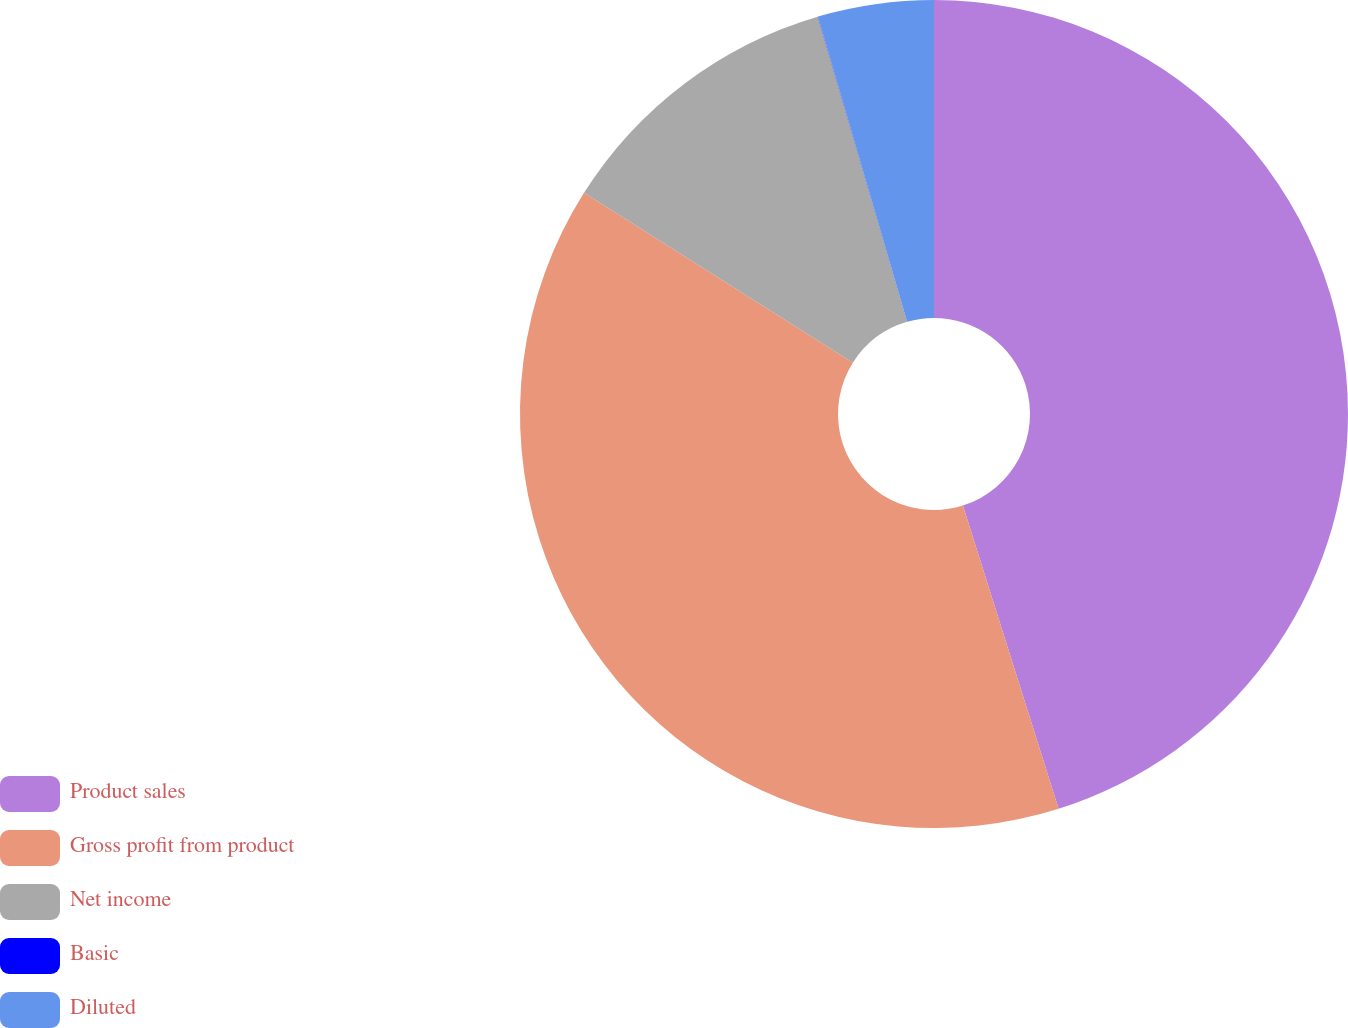Convert chart. <chart><loc_0><loc_0><loc_500><loc_500><pie_chart><fcel>Product sales<fcel>Gross profit from product<fcel>Net income<fcel>Basic<fcel>Diluted<nl><fcel>45.13%<fcel>38.83%<fcel>11.5%<fcel>0.01%<fcel>4.52%<nl></chart> 